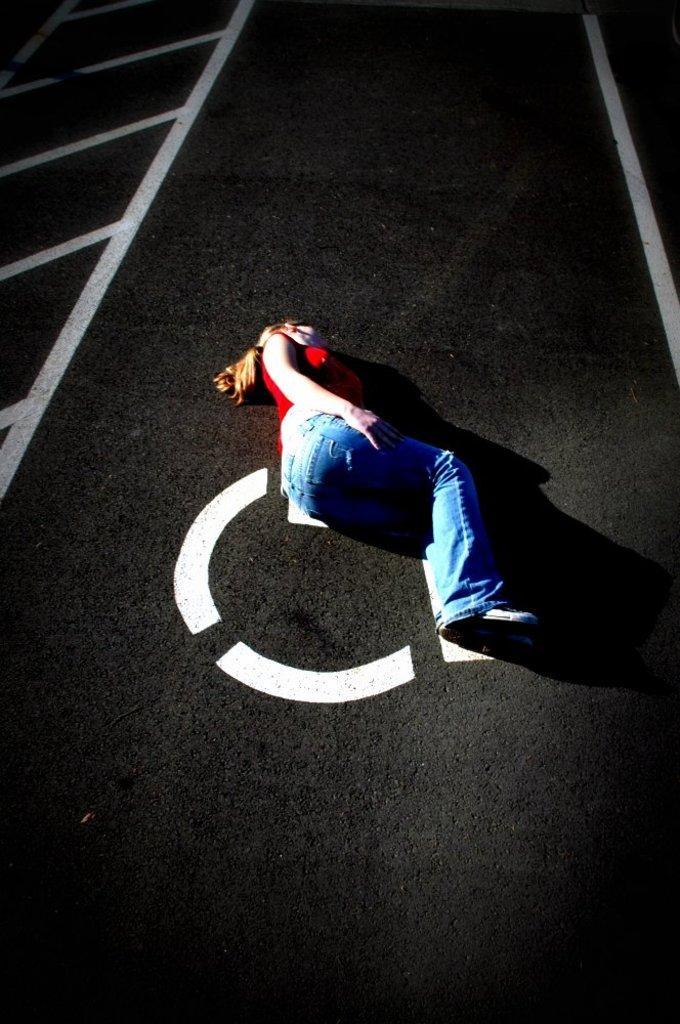In one or two sentences, can you explain what this image depicts? There is one person lying on the floor as we can see in the middle of this image. We can see the white color paint on the floor. 